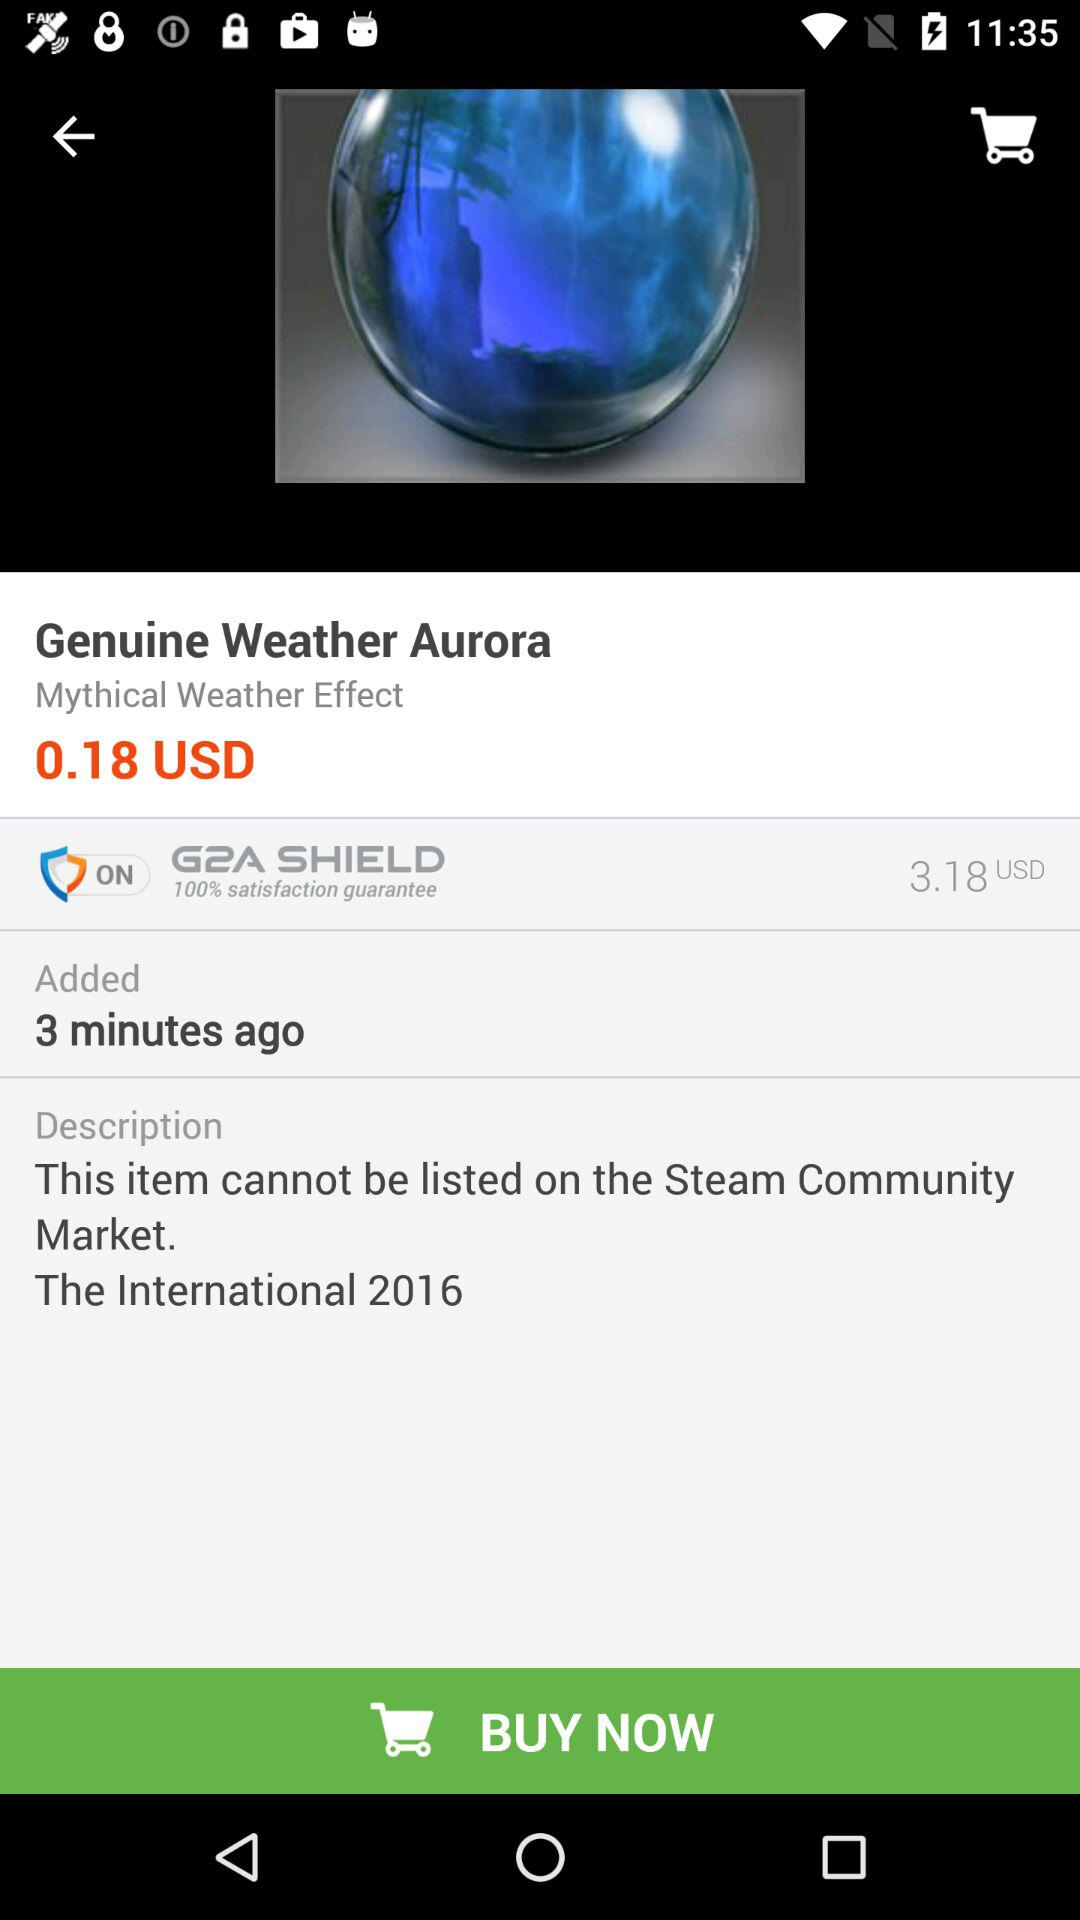When was the item added? The item was added 3 minutes ago. 